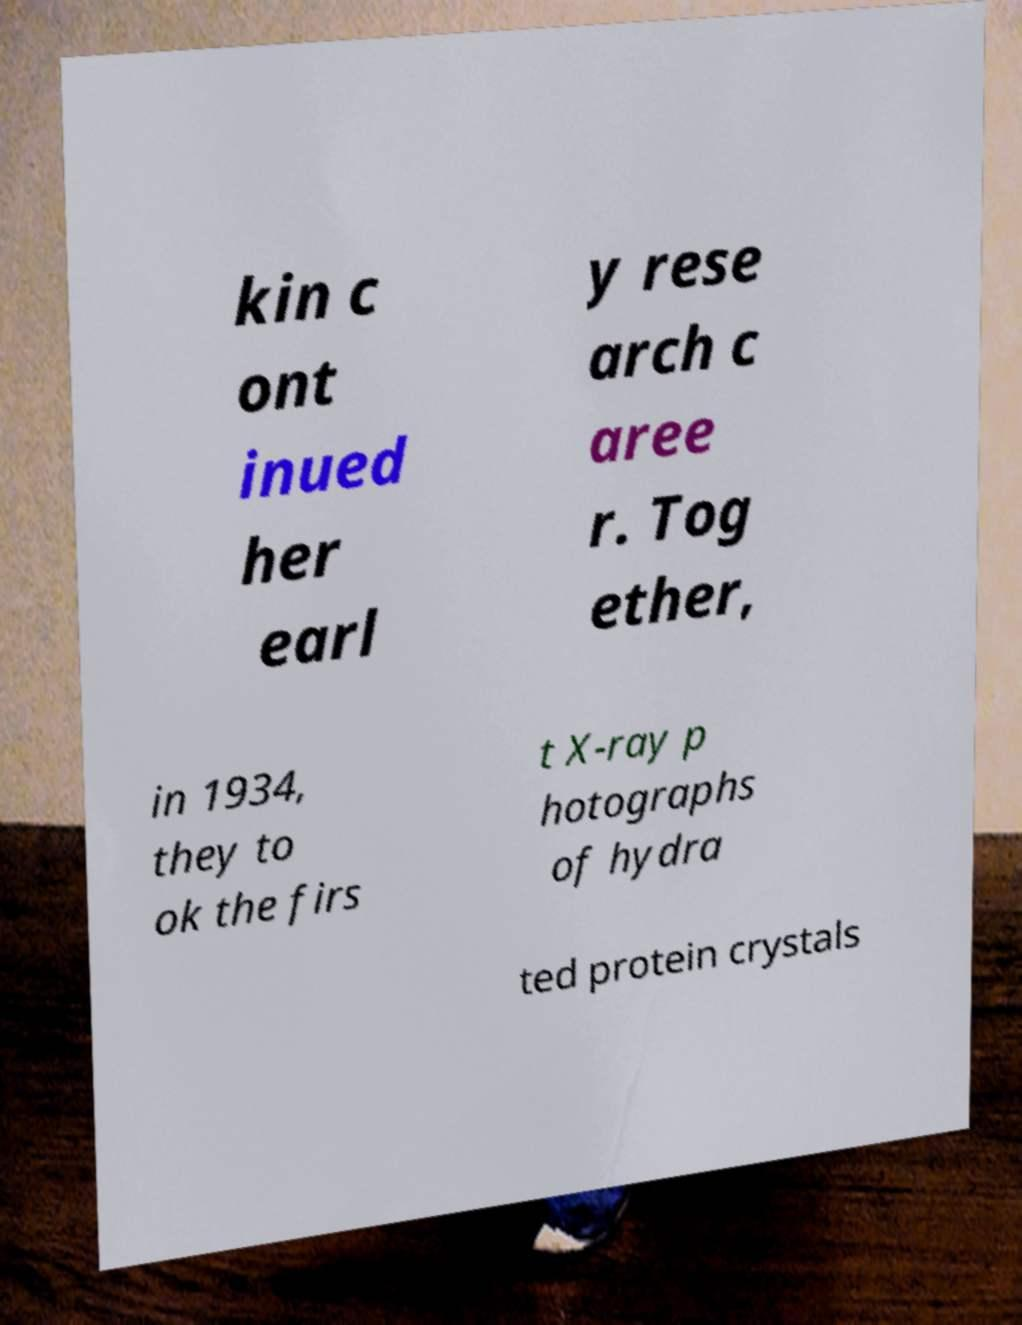What messages or text are displayed in this image? I need them in a readable, typed format. kin c ont inued her earl y rese arch c aree r. Tog ether, in 1934, they to ok the firs t X-ray p hotographs of hydra ted protein crystals 